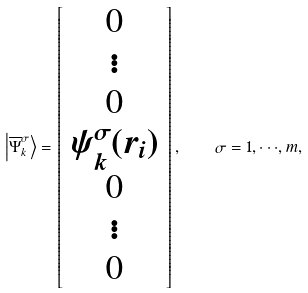Convert formula to latex. <formula><loc_0><loc_0><loc_500><loc_500>\left | \overline { \Psi } _ { k } ^ { \sigma } \right \rangle = \left [ \begin{array} { c } 0 \\ \vdots \\ 0 \\ \psi _ { k } ^ { \sigma } ( { r } _ { i } ) \\ 0 \\ \vdots \\ 0 \end{array} \right ] , \quad \sigma = 1 , \cdot \cdot \cdot , m ,</formula> 